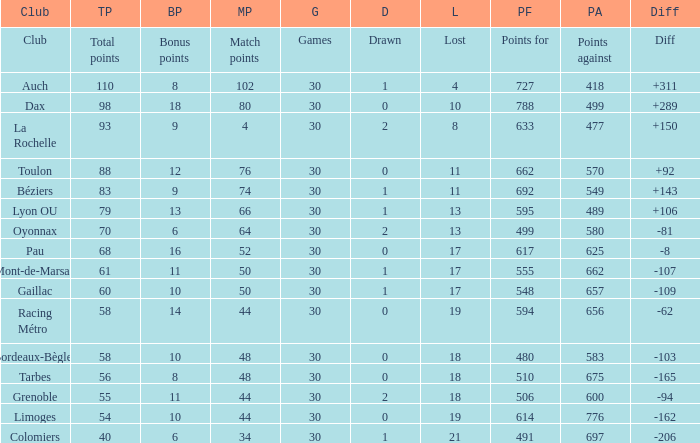What is the value of match points when the points for is 570? 76.0. 